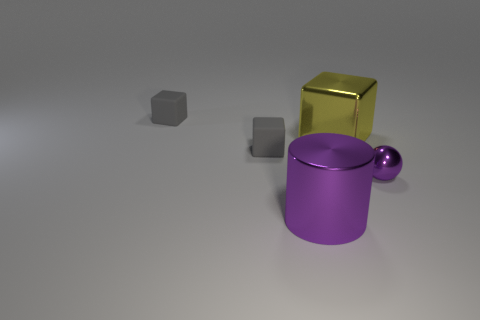Subtract all cyan blocks. Subtract all cyan balls. How many blocks are left? 3 Add 5 tiny shiny spheres. How many objects exist? 10 Subtract all blocks. How many objects are left? 2 Subtract 1 purple cylinders. How many objects are left? 4 Subtract all metal blocks. Subtract all brown objects. How many objects are left? 4 Add 1 yellow things. How many yellow things are left? 2 Add 3 tiny purple things. How many tiny purple things exist? 4 